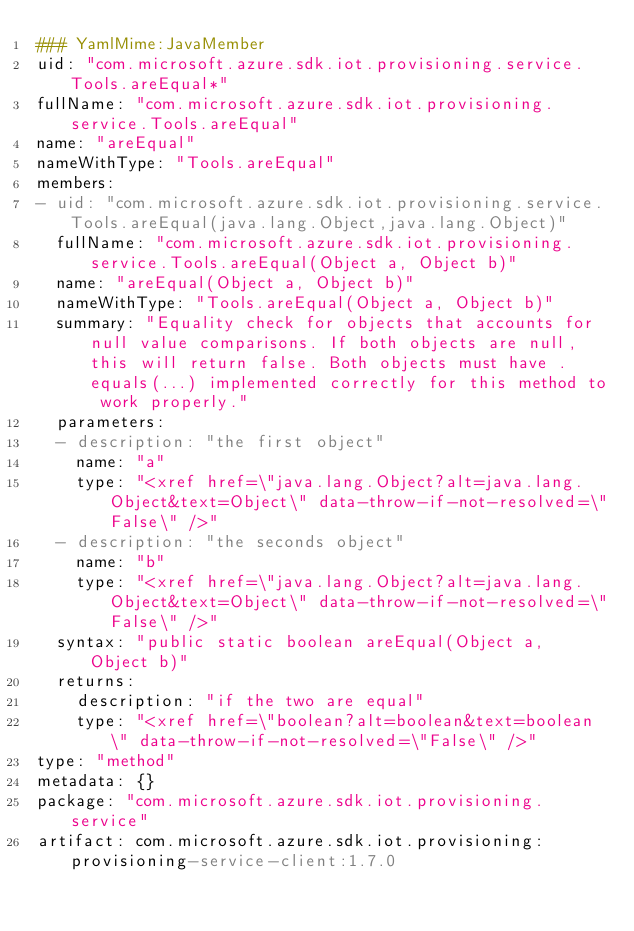Convert code to text. <code><loc_0><loc_0><loc_500><loc_500><_YAML_>### YamlMime:JavaMember
uid: "com.microsoft.azure.sdk.iot.provisioning.service.Tools.areEqual*"
fullName: "com.microsoft.azure.sdk.iot.provisioning.service.Tools.areEqual"
name: "areEqual"
nameWithType: "Tools.areEqual"
members:
- uid: "com.microsoft.azure.sdk.iot.provisioning.service.Tools.areEqual(java.lang.Object,java.lang.Object)"
  fullName: "com.microsoft.azure.sdk.iot.provisioning.service.Tools.areEqual(Object a, Object b)"
  name: "areEqual(Object a, Object b)"
  nameWithType: "Tools.areEqual(Object a, Object b)"
  summary: "Equality check for objects that accounts for null value comparisons. If both objects are null, this will return false. Both objects must have .equals(...) implemented correctly for this method to work properly."
  parameters:
  - description: "the first object"
    name: "a"
    type: "<xref href=\"java.lang.Object?alt=java.lang.Object&text=Object\" data-throw-if-not-resolved=\"False\" />"
  - description: "the seconds object"
    name: "b"
    type: "<xref href=\"java.lang.Object?alt=java.lang.Object&text=Object\" data-throw-if-not-resolved=\"False\" />"
  syntax: "public static boolean areEqual(Object a, Object b)"
  returns:
    description: "if the two are equal"
    type: "<xref href=\"boolean?alt=boolean&text=boolean\" data-throw-if-not-resolved=\"False\" />"
type: "method"
metadata: {}
package: "com.microsoft.azure.sdk.iot.provisioning.service"
artifact: com.microsoft.azure.sdk.iot.provisioning:provisioning-service-client:1.7.0
</code> 